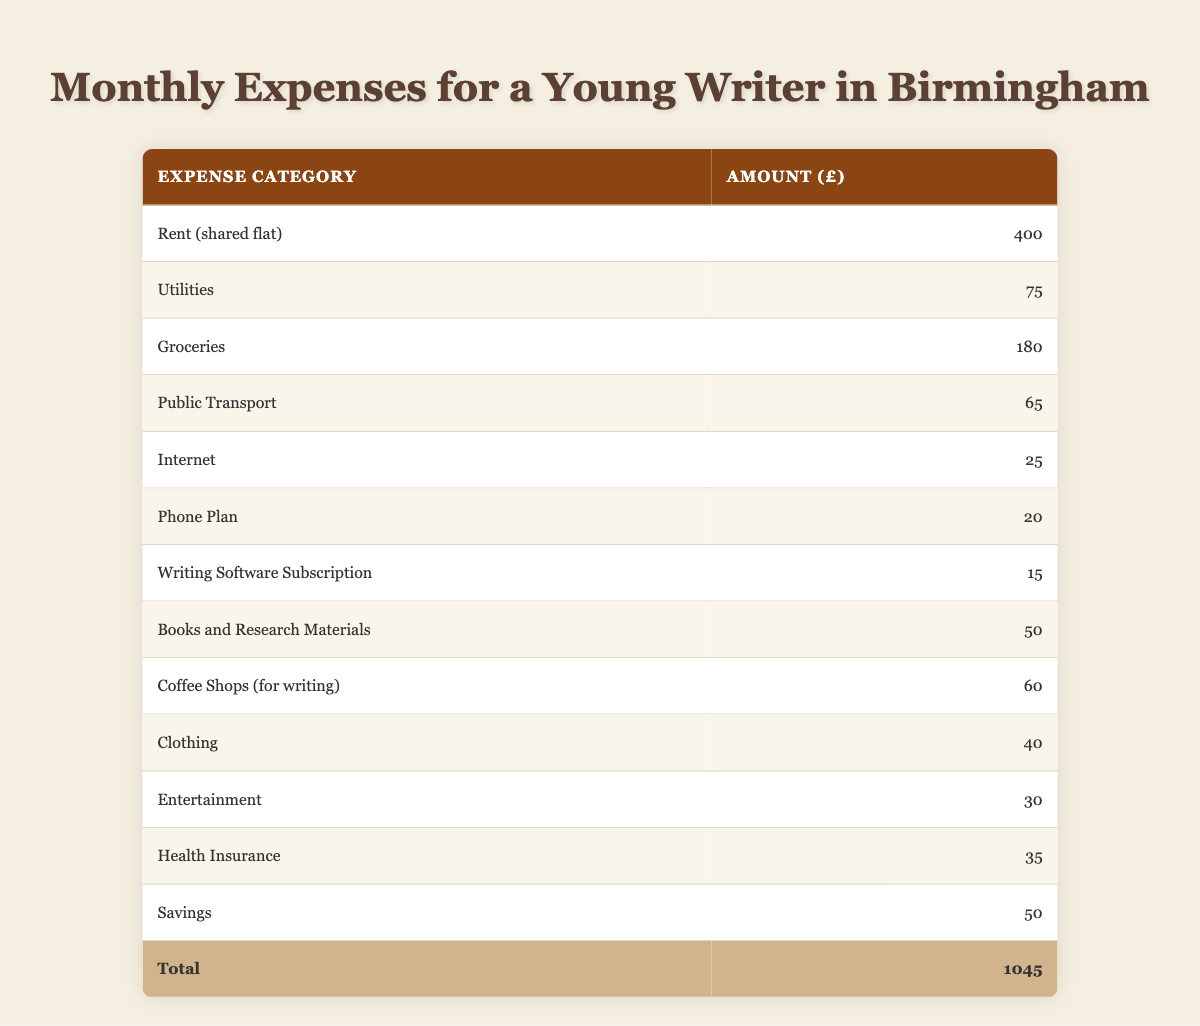What is the total monthly expense for the household? The total expenses can be found in the last row of the table, which states that the total is £1045.
Answer: £1045 How much is spent on groceries? The amount allocated for groceries is directly listed in the table, which shows £180 is spent on this category.
Answer: £180 Is the amount spent on utilities greater than the combined expenses for the writing software subscription and phone plan? The amount for utilities is £75. The combined expenses for the writing software subscription (£15) and phone plan (£20) is £35. Since £75 is greater than £35, the answer is yes.
Answer: Yes What is the difference between the expenses for rent and the expenses for clothing? The rent is £400 and clothing costs £40. The difference is calculated as £400 - £40 = £360.
Answer: £360 On average, how much is spent on entertainment and coffee shops combined? The expense for entertainment is £30 and for coffee shops it is £60. Combined, the total is £30 + £60 = £90. To find the average, we divide by 2, resulting in £90 / 2 = £45.
Answer: £45 Does the budget allocate more money for public transport than for internet expenses? The public transport expense is £65, while the internet expense is £25. Since £65 is greater than £25, the answer is yes.
Answer: Yes What percentage of the total expenses is allocated for savings? Savings amount to £50. To find the percentage of the total (£1045), we calculate (£50 / £1045) × 100, which results in approximately 4.79%.
Answer: 4.79% What is the combined total for health insurance and utilities? Health insurance costs £35 and utilities £75. Adding these together gives £35 + £75 = £110 for the combined total.
Answer: £110 If one were to cut the coffee shop expense in half, how much would that save monthly? The current expense for coffee shops is £60. Halving this amount results in £60 / 2 = £30. Thus, the saving would be £30.
Answer: £30 